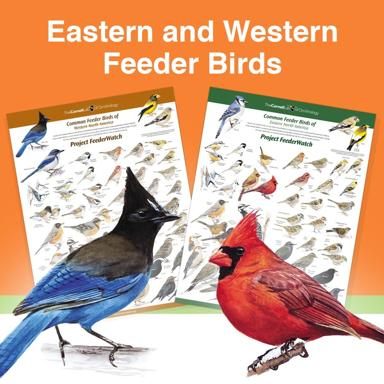Can you tell me how these bird posters can be used in educational settings? These bird posters are excellent resources for educational settings, providing a visual aid for students to learn about biodiversity and the importance of regional habitats. Teachers can use these posters to illustrate lessons on adaptation, ecology, and conservation. They also offer a hands-on tool for students to engage in bird identification exercises, fostering a deeper connection with local and national wildlife species.  What activities could these posters inspire in young bird watchers? These posters can inspire various activities such as bird watching scavenger hunts, where young enthusiasts use the posters as a checklist to find and identify birds in their local areas. Another activity could be a comparative study where students document the birds they see, compare them to the species on the posters, and learn about their habits and roles in the ecosystem. This not only enhances observational skills but also instills a sense of stewardship for the environment. 